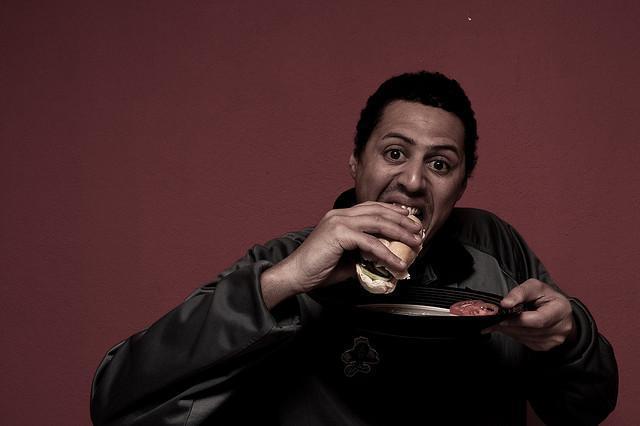How many fruits are there?
Give a very brief answer. 1. How many umbrellas are there?
Give a very brief answer. 0. 